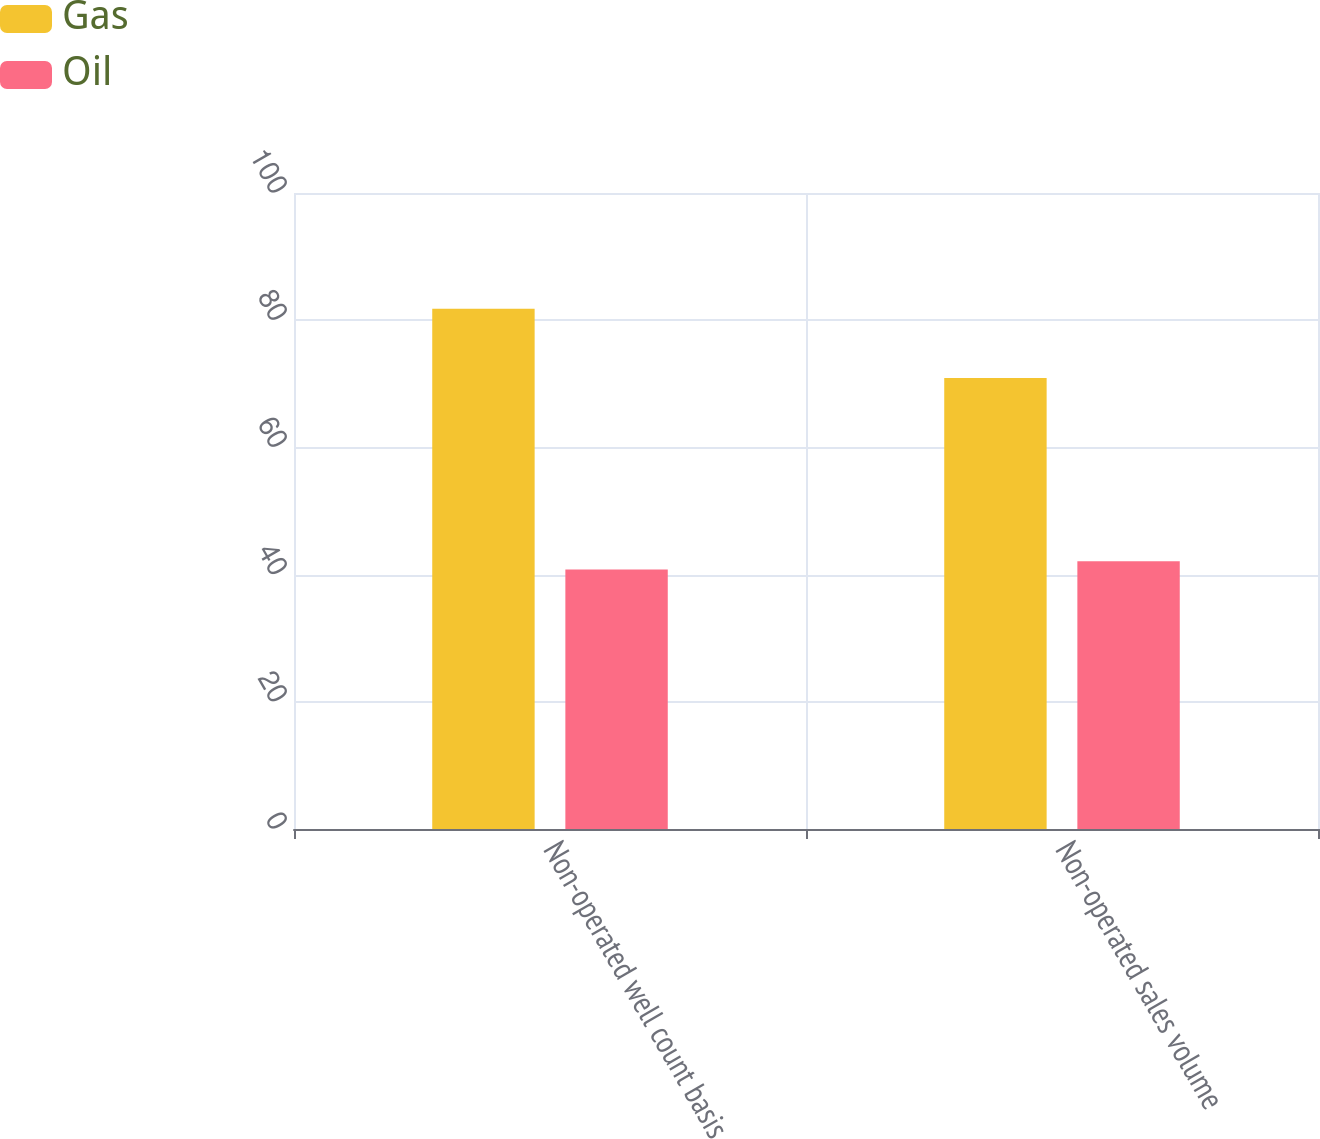<chart> <loc_0><loc_0><loc_500><loc_500><stacked_bar_chart><ecel><fcel>Non-operated well count basis<fcel>Non-operated sales volume<nl><fcel>Gas<fcel>81.8<fcel>70.9<nl><fcel>Oil<fcel>40.8<fcel>42.1<nl></chart> 